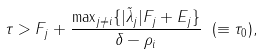Convert formula to latex. <formula><loc_0><loc_0><loc_500><loc_500>\tau > F _ { j } + \frac { \max _ { j \not = i } \{ | \tilde { \lambda } _ { j } | F _ { j } + E _ { j } \} } { \delta - \rho _ { i } } \ ( \equiv \tau _ { 0 } ) ,</formula> 